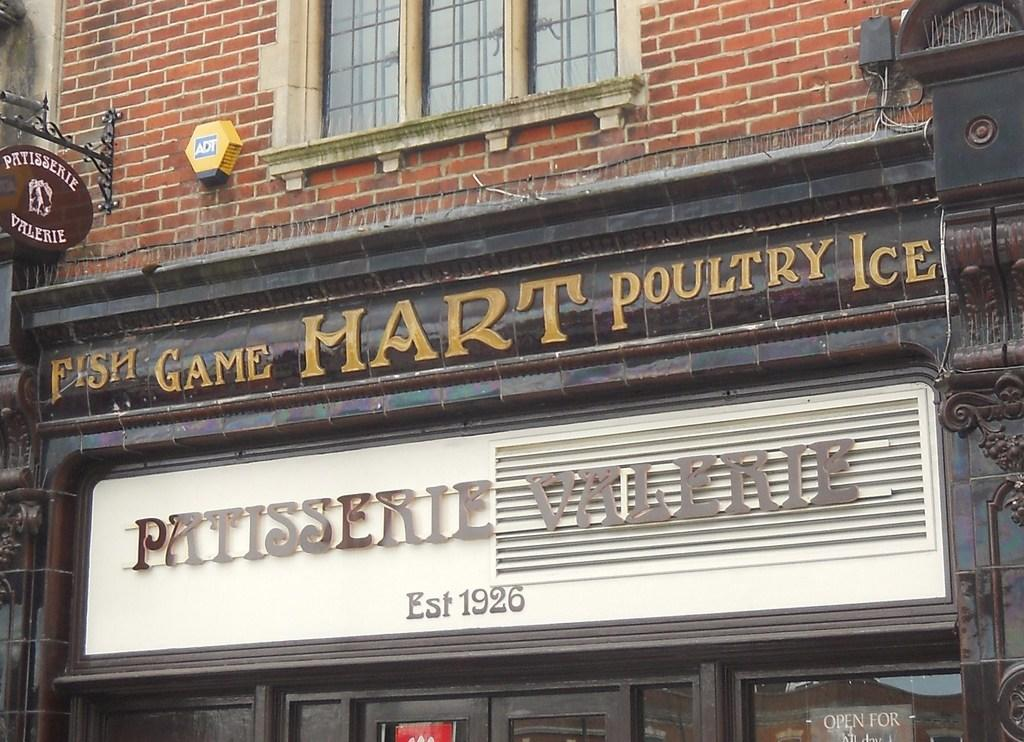What type of establishment is depicted in the image? There is a store in the picture. What can be seen on the store? There is something written on the store. What feature is present above the store? There is a glass window above the store. How many cars are parked in front of the store in the image? There is no information about cars in the image; it only shows a store with something written on it and a glass window above it. 